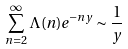<formula> <loc_0><loc_0><loc_500><loc_500>\sum _ { n = 2 } ^ { \infty } \Lambda ( n ) e ^ { - n y } \sim \frac { 1 } { y }</formula> 